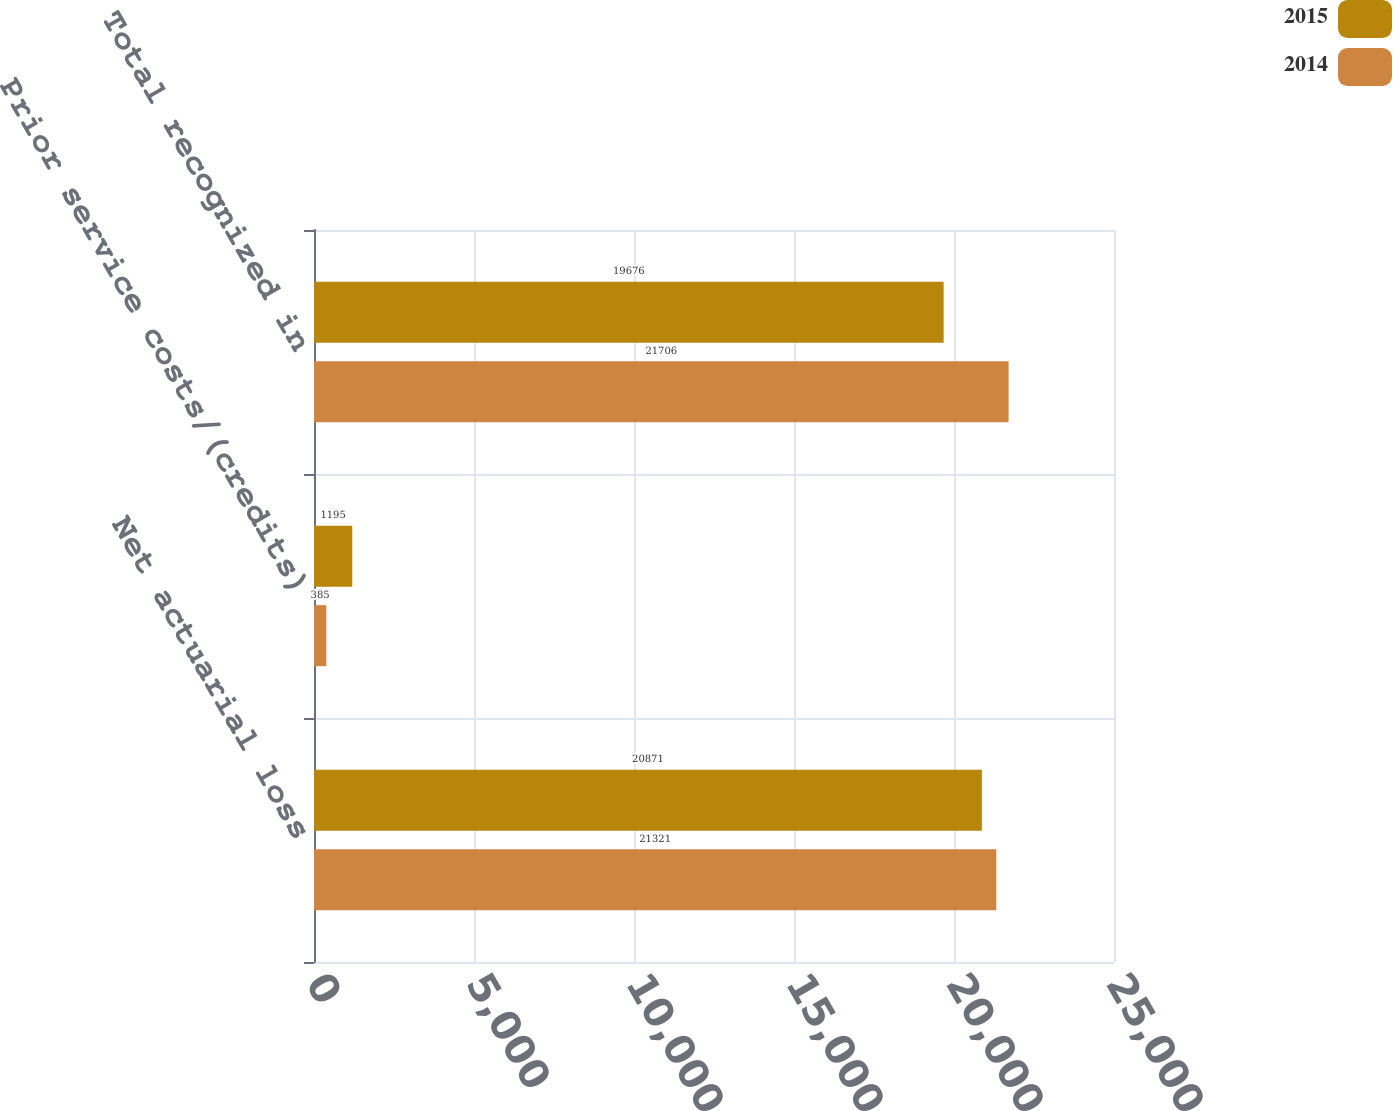Convert chart to OTSL. <chart><loc_0><loc_0><loc_500><loc_500><stacked_bar_chart><ecel><fcel>Net actuarial loss<fcel>Prior service costs/(credits)<fcel>Total recognized in<nl><fcel>2015<fcel>20871<fcel>1195<fcel>19676<nl><fcel>2014<fcel>21321<fcel>385<fcel>21706<nl></chart> 